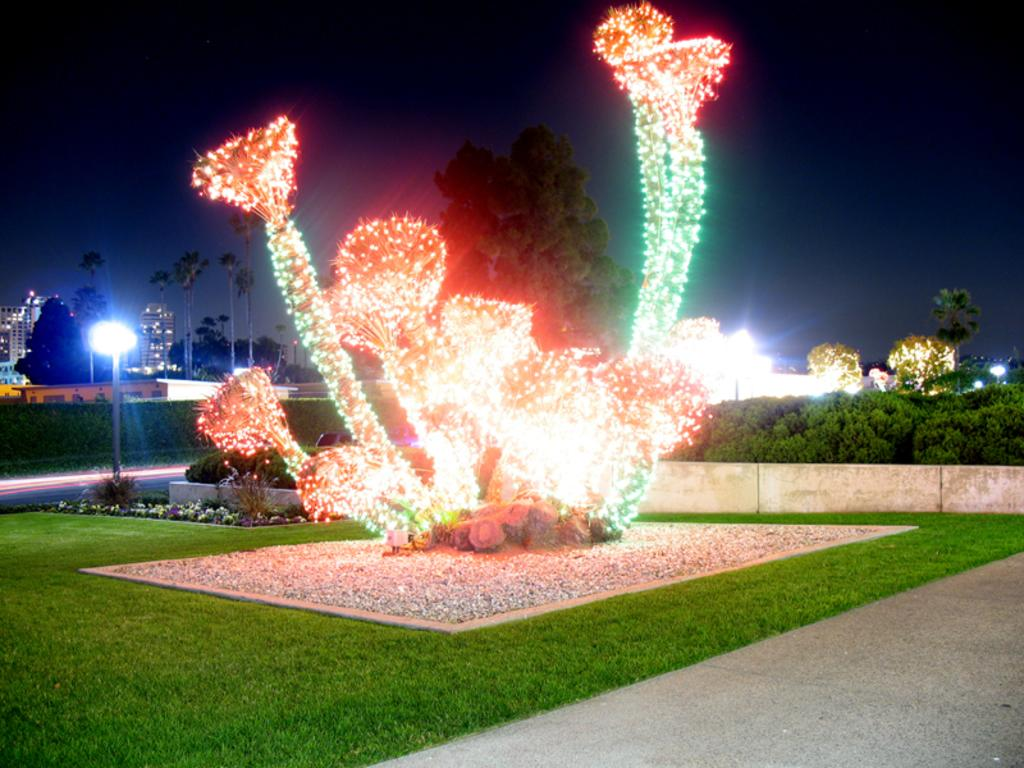What is the main subject of the image? The main subject of the image is a tree decorated with lights. Can you describe the decorations on the tree? The tree is decorated with lights. What else can be seen in the background of the image? There are other trees visible in the background of the image. Can you tell me how many giraffes are standing near the tree in the image? There are no giraffes present in the image. What type of screw is being used to attach the lights to the tree in the image? There is no screw visible in the image, as the lights appear to be attached to the tree in a different manner. 